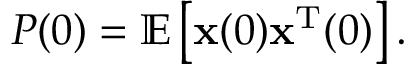<formula> <loc_0><loc_0><loc_500><loc_500>P ( 0 ) = \mathbb { E } \left [ { x } ( 0 ) { x } ^ { T } ( 0 ) \right ] .</formula> 